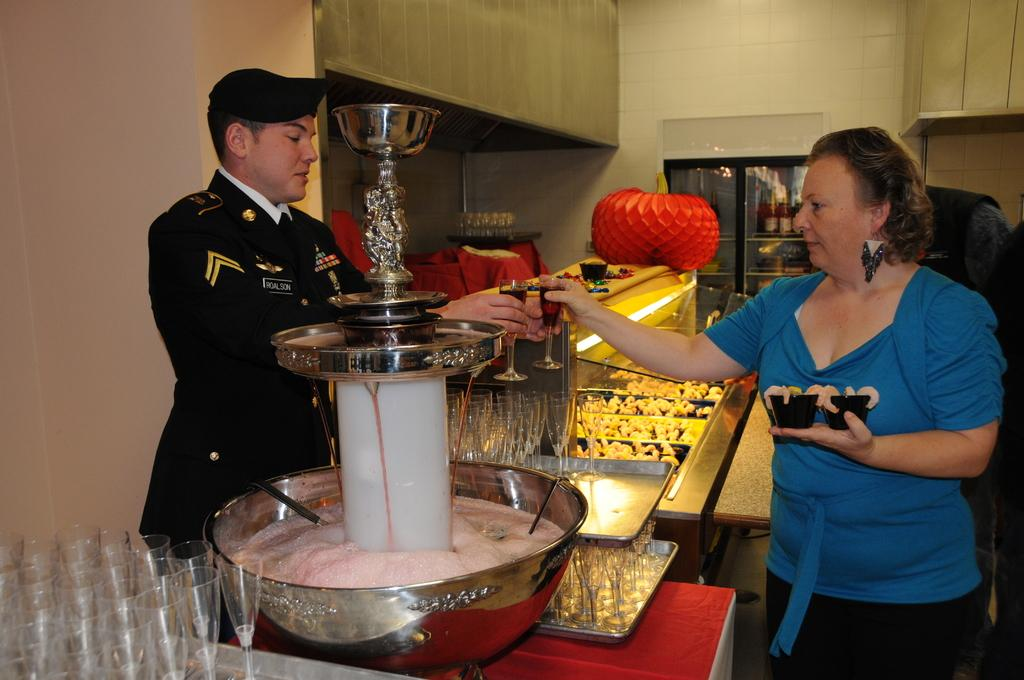How many people are present in the image? There are two people in the image. Where is the first person located in the image? One person is standing on the left side. Where is the second person located in the image? One person is standing on the right side. What are the people holding in the image? Both people are holding glasses. What type of war is depicted in the image? There is no war depicted in the image; it features two people standing and holding glasses. What achievements have the people in the image accomplished? The image does not provide information about any achievements the people may have accomplished. 